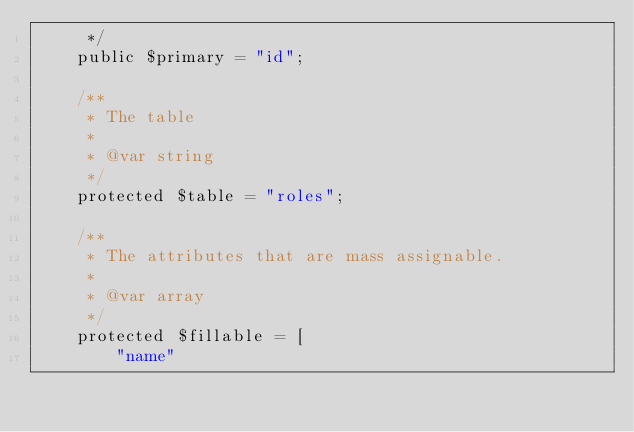Convert code to text. <code><loc_0><loc_0><loc_500><loc_500><_PHP_>     */
    public $primary = "id";
    
    /**
     * The table
     * 
     * @var string
     */
    protected $table = "roles";

    /**
     * The attributes that are mass assignable.
     *
     * @var array
     */
    protected $fillable = [
        "name"</code> 